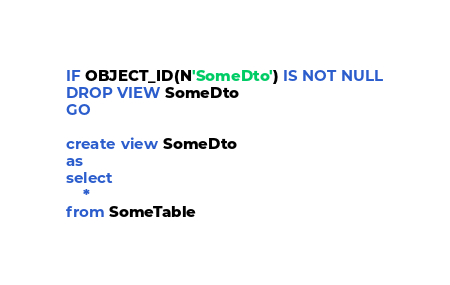Convert code to text. <code><loc_0><loc_0><loc_500><loc_500><_SQL_>IF OBJECT_ID(N'SomeDto') IS NOT NULL
DROP VIEW SomeDto
GO

create view SomeDto
as
select 
    *
from SomeTable
</code> 